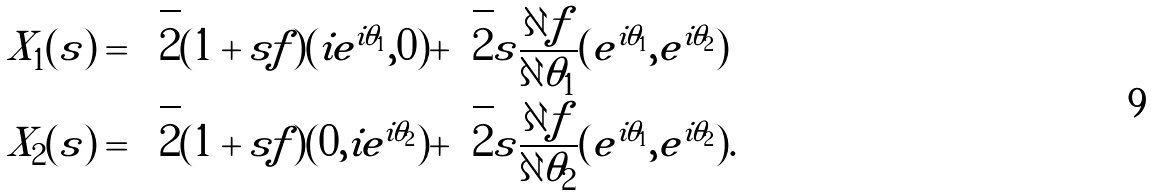Convert formula to latex. <formula><loc_0><loc_0><loc_500><loc_500>X _ { 1 } ( s ) & = \sqrt { 2 } ( 1 + s f ) ( i e ^ { i \theta _ { 1 } } , 0 ) + \sqrt { 2 } s \frac { \partial f } { \partial \theta _ { 1 } } ( e ^ { i \theta _ { 1 } } , e ^ { i \theta _ { 2 } } ) \\ X _ { 2 } ( s ) & = \sqrt { 2 } ( 1 + s f ) ( 0 , i e ^ { i \theta _ { 2 } } ) + \sqrt { 2 } s \frac { \partial f } { \partial \theta _ { 2 } } ( e ^ { i \theta _ { 1 } } , e ^ { i \theta _ { 2 } } ) .</formula> 